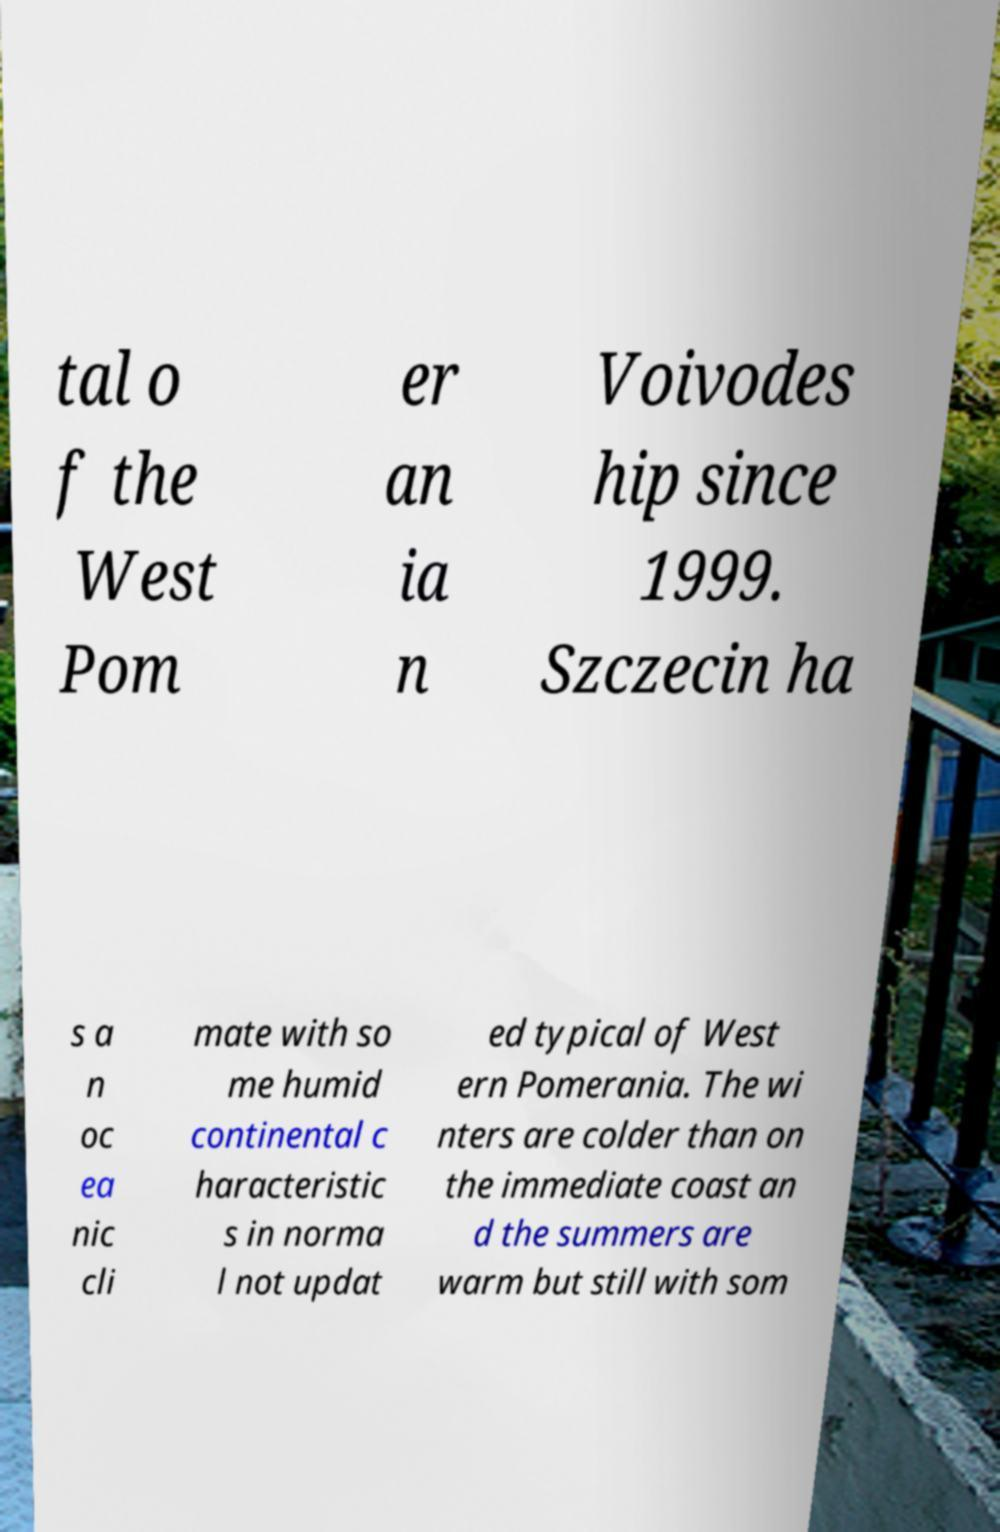Could you assist in decoding the text presented in this image and type it out clearly? tal o f the West Pom er an ia n Voivodes hip since 1999. Szczecin ha s a n oc ea nic cli mate with so me humid continental c haracteristic s in norma l not updat ed typical of West ern Pomerania. The wi nters are colder than on the immediate coast an d the summers are warm but still with som 